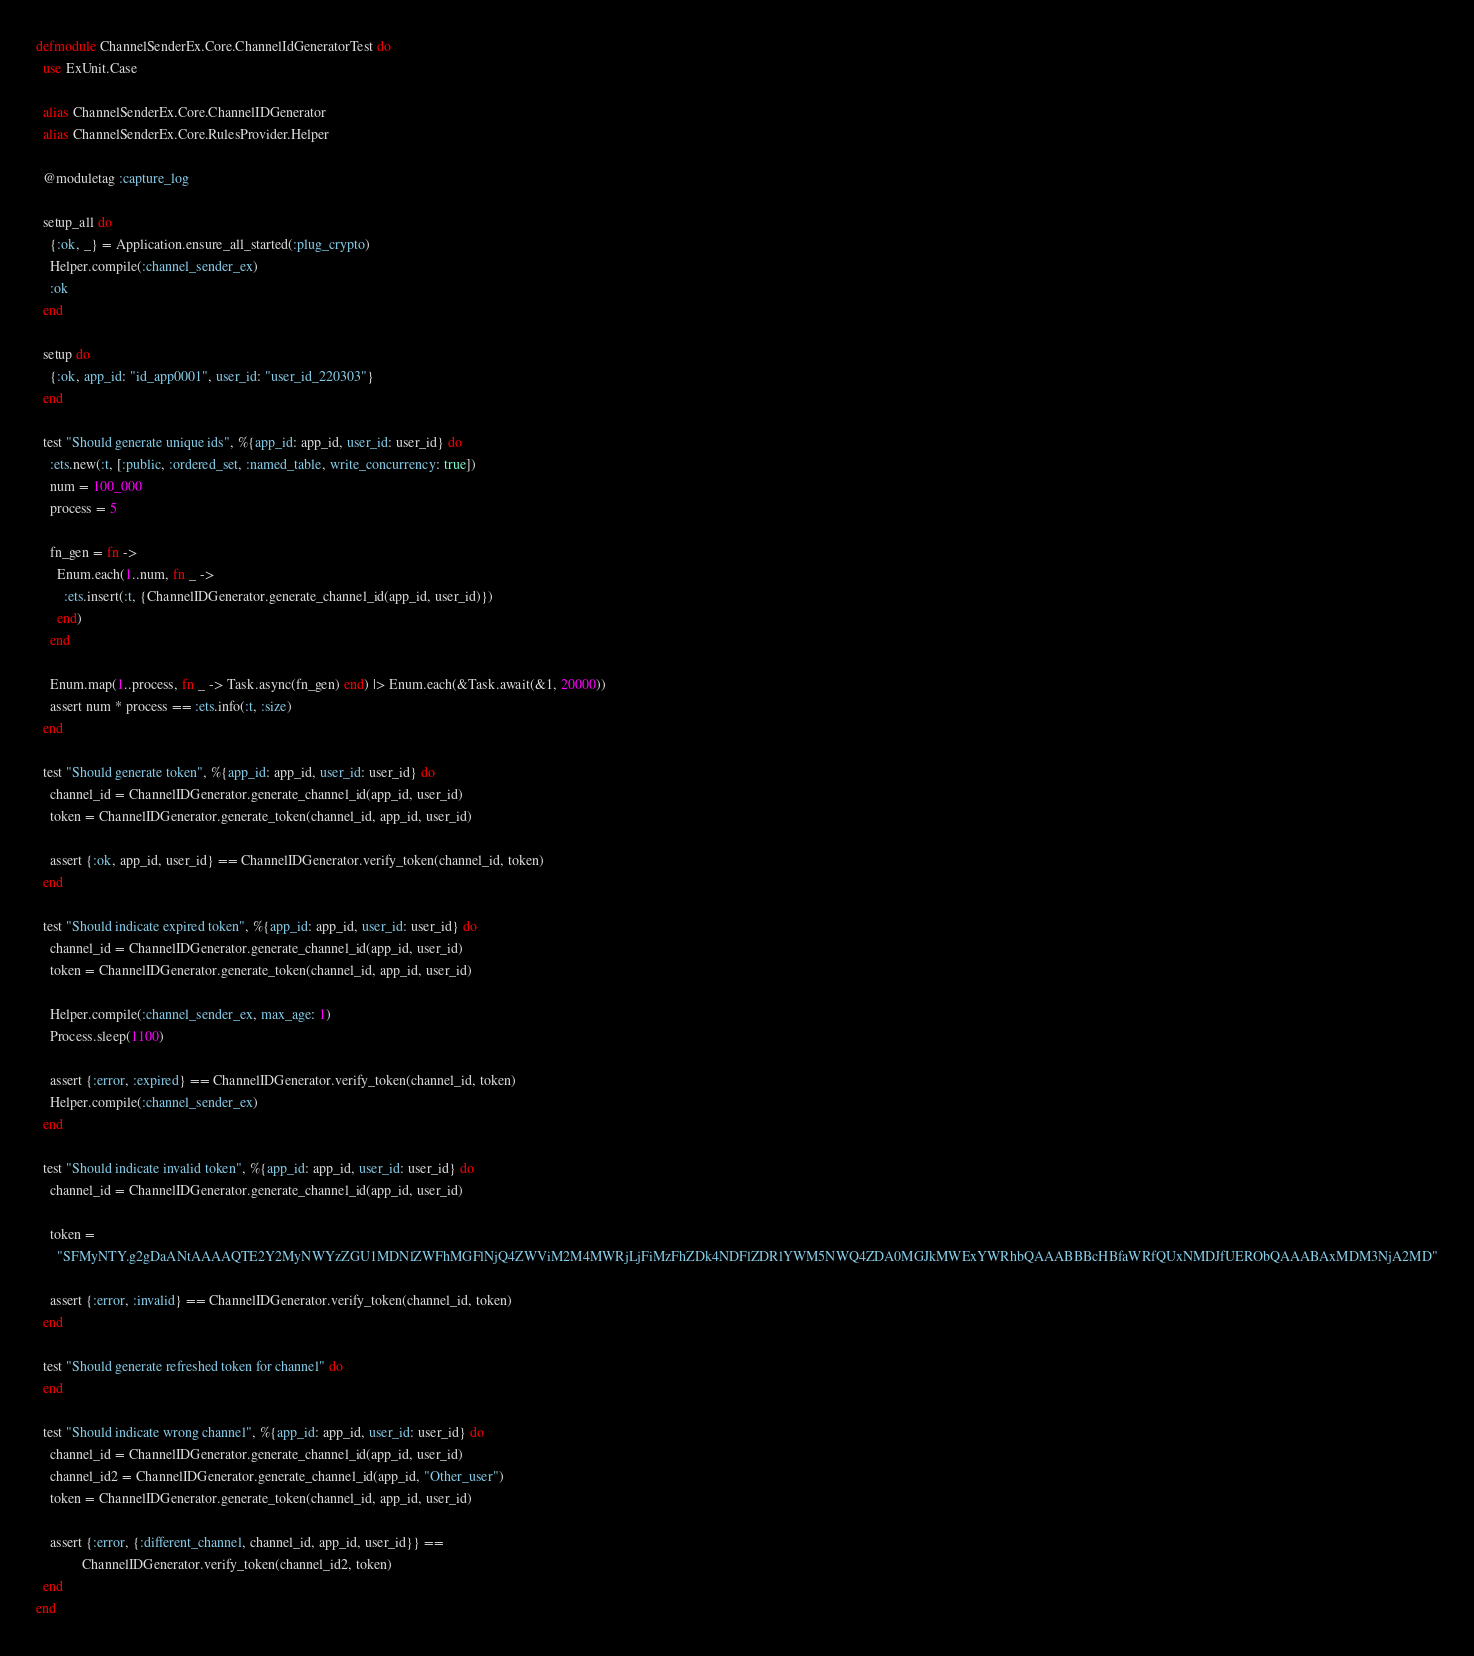Convert code to text. <code><loc_0><loc_0><loc_500><loc_500><_Elixir_>defmodule ChannelSenderEx.Core.ChannelIdGeneratorTest do
  use ExUnit.Case

  alias ChannelSenderEx.Core.ChannelIDGenerator
  alias ChannelSenderEx.Core.RulesProvider.Helper

  @moduletag :capture_log

  setup_all do
    {:ok, _} = Application.ensure_all_started(:plug_crypto)
    Helper.compile(:channel_sender_ex)
    :ok
  end

  setup do
    {:ok, app_id: "id_app0001", user_id: "user_id_220303"}
  end

  test "Should generate unique ids", %{app_id: app_id, user_id: user_id} do
    :ets.new(:t, [:public, :ordered_set, :named_table, write_concurrency: true])
    num = 100_000
    process = 5

    fn_gen = fn ->
      Enum.each(1..num, fn _ ->
        :ets.insert(:t, {ChannelIDGenerator.generate_channel_id(app_id, user_id)})
      end)
    end

    Enum.map(1..process, fn _ -> Task.async(fn_gen) end) |> Enum.each(&Task.await(&1, 20000))
    assert num * process == :ets.info(:t, :size)
  end

  test "Should generate token", %{app_id: app_id, user_id: user_id} do
    channel_id = ChannelIDGenerator.generate_channel_id(app_id, user_id)
    token = ChannelIDGenerator.generate_token(channel_id, app_id, user_id)

    assert {:ok, app_id, user_id} == ChannelIDGenerator.verify_token(channel_id, token)
  end

  test "Should indicate expired token", %{app_id: app_id, user_id: user_id} do
    channel_id = ChannelIDGenerator.generate_channel_id(app_id, user_id)
    token = ChannelIDGenerator.generate_token(channel_id, app_id, user_id)

    Helper.compile(:channel_sender_ex, max_age: 1)
    Process.sleep(1100)

    assert {:error, :expired} == ChannelIDGenerator.verify_token(channel_id, token)
    Helper.compile(:channel_sender_ex)
  end

  test "Should indicate invalid token", %{app_id: app_id, user_id: user_id} do
    channel_id = ChannelIDGenerator.generate_channel_id(app_id, user_id)

    token =
      "SFMyNTY.g2gDaANtAAAAQTE2Y2MyNWYzZGU1MDNlZWFhMGFlNjQ4ZWViM2M4MWRjLjFiMzFhZDk4NDFlZDRlYWM5NWQ4ZDA0MGJkMWExYWRhbQAAABBBcHBfaWRfQUxNMDJfUERObQAAABAxMDM3NjA2MD"

    assert {:error, :invalid} == ChannelIDGenerator.verify_token(channel_id, token)
  end

  test "Should generate refreshed token for channel" do
  end

  test "Should indicate wrong channel", %{app_id: app_id, user_id: user_id} do
    channel_id = ChannelIDGenerator.generate_channel_id(app_id, user_id)
    channel_id2 = ChannelIDGenerator.generate_channel_id(app_id, "Other_user")
    token = ChannelIDGenerator.generate_token(channel_id, app_id, user_id)

    assert {:error, {:different_channel, channel_id, app_id, user_id}} ==
             ChannelIDGenerator.verify_token(channel_id2, token)
  end
end
</code> 